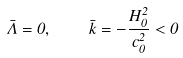<formula> <loc_0><loc_0><loc_500><loc_500>\bar { \Lambda } = 0 , \quad \bar { k } = - \frac { H _ { 0 } ^ { 2 } } { c _ { 0 } ^ { 2 } } < 0</formula> 